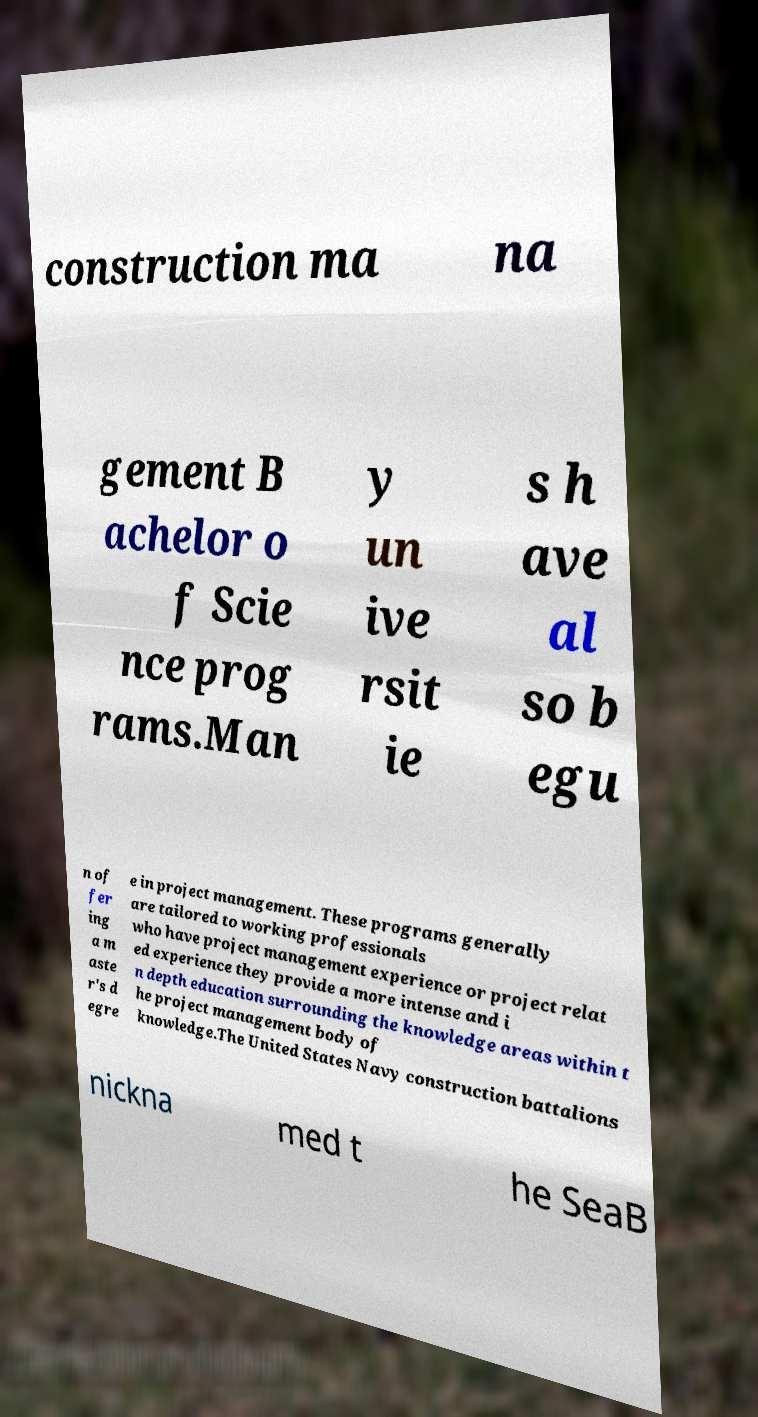Can you accurately transcribe the text from the provided image for me? construction ma na gement B achelor o f Scie nce prog rams.Man y un ive rsit ie s h ave al so b egu n of fer ing a m aste r's d egre e in project management. These programs generally are tailored to working professionals who have project management experience or project relat ed experience they provide a more intense and i n depth education surrounding the knowledge areas within t he project management body of knowledge.The United States Navy construction battalions nickna med t he SeaB 